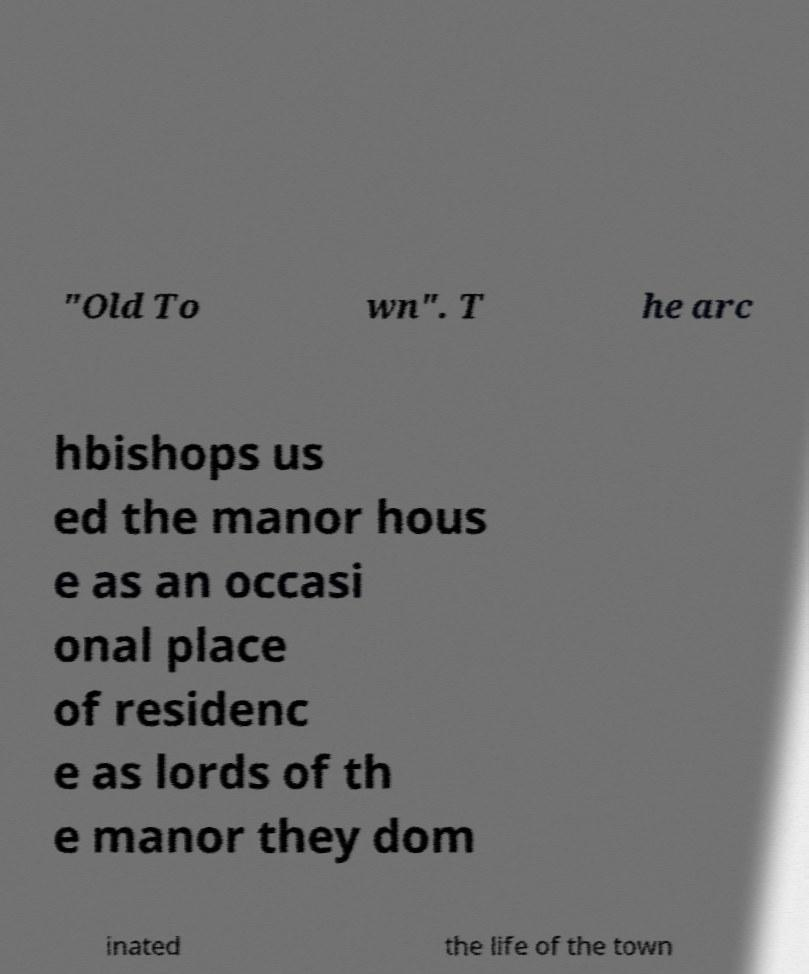Can you accurately transcribe the text from the provided image for me? "Old To wn". T he arc hbishops us ed the manor hous e as an occasi onal place of residenc e as lords of th e manor they dom inated the life of the town 